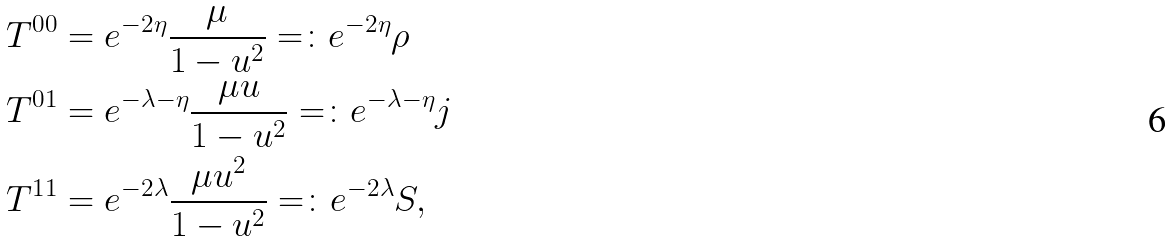<formula> <loc_0><loc_0><loc_500><loc_500>T ^ { 0 0 } & = e ^ { - 2 \eta } \frac { \mu } { 1 - u ^ { 2 } } = \colon e ^ { - 2 \eta } \rho \\ T ^ { 0 1 } & = e ^ { - \lambda - \eta } \frac { \mu u } { 1 - u ^ { 2 } } = \colon e ^ { - \lambda - \eta } j \\ T ^ { 1 1 } & = e ^ { - 2 \lambda } \frac { \mu u ^ { 2 } } { 1 - u ^ { 2 } } = \colon e ^ { - 2 \lambda } S ,</formula> 